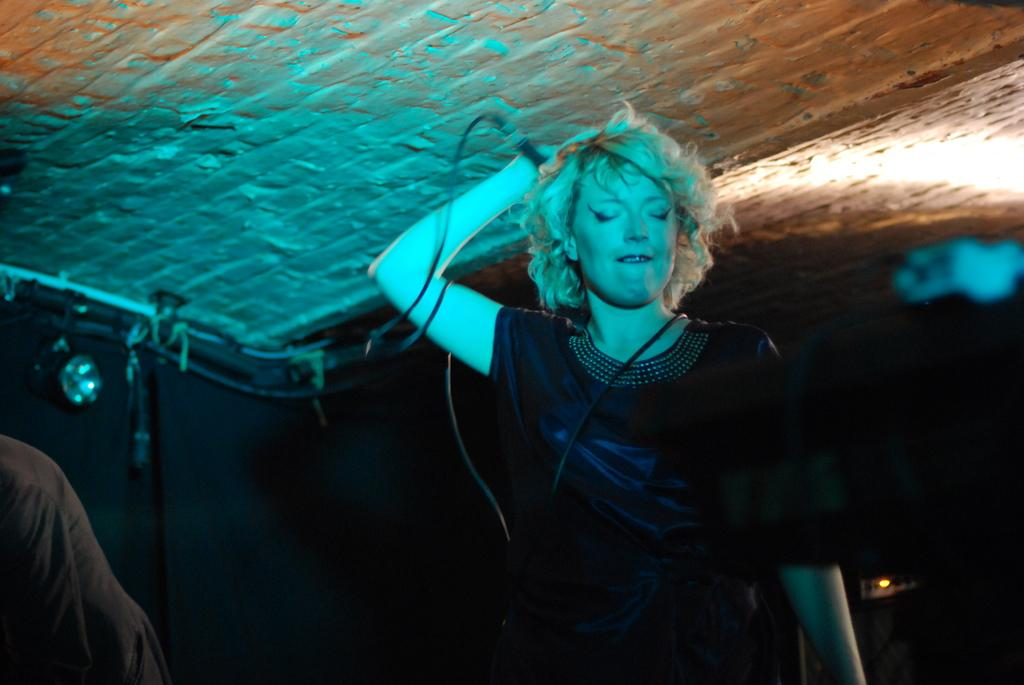Who is the main subject in the image? There is a woman in the image. What is the woman holding in her hand? The woman is holding a mic in her hand. What can be seen connected to the mic? There is a wire visible in the image. What part of the room can be seen in the image? The ceiling is visible in the image. How would you describe the lighting in the image? The background of the image appears to be dark. What type of sail can be seen in the image? There is no sail present in the image. Who is the governor in the image? There is no governor present in the image. 